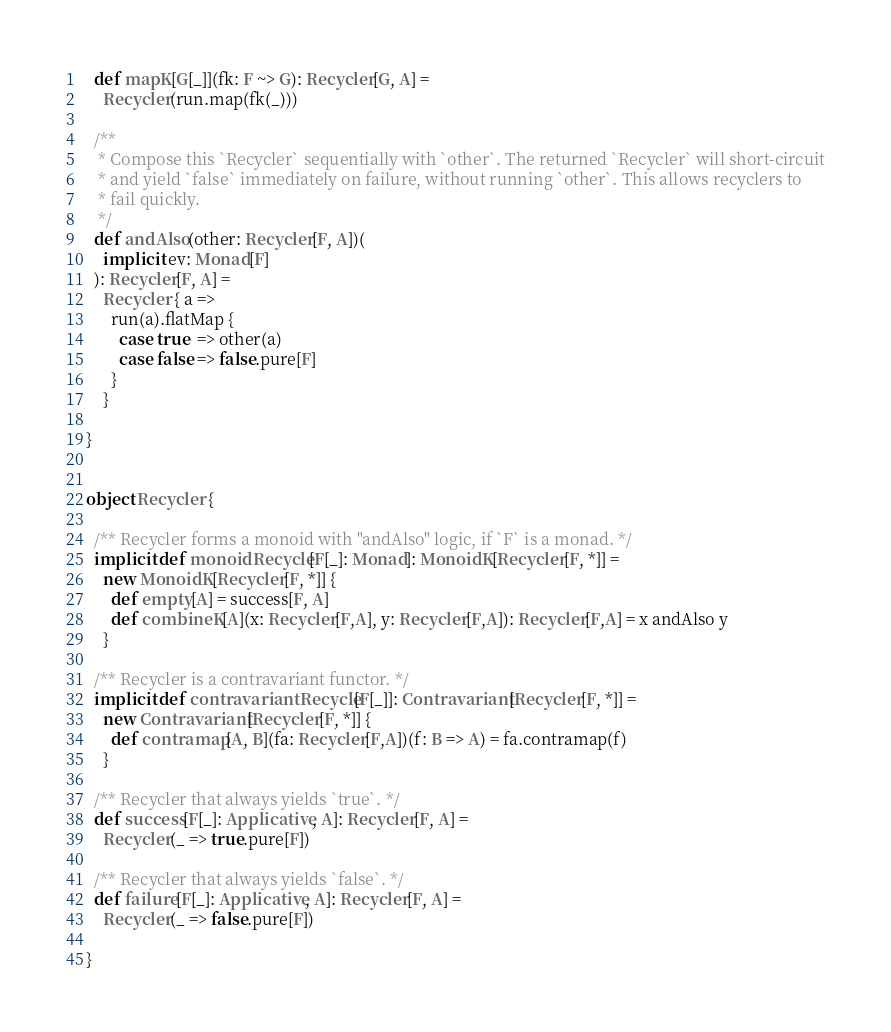Convert code to text. <code><loc_0><loc_0><loc_500><loc_500><_Scala_>  def mapK[G[_]](fk: F ~> G): Recycler[G, A] =
    Recycler(run.map(fk(_)))

  /**
   * Compose this `Recycler` sequentially with `other`. The returned `Recycler` will short-circuit
   * and yield `false` immediately on failure, without running `other`. This allows recyclers to
   * fail quickly.
   */
  def andAlso(other: Recycler[F, A])(
    implicit ev: Monad[F]
  ): Recycler[F, A] =
    Recycler { a =>
      run(a).flatMap {
        case true  => other(a)
        case false => false.pure[F]
      }
    }

}


object Recycler {

  /** Recycler forms a monoid with "andAlso" logic, if `F` is a monad. */
  implicit def monoidRecycle[F[_]: Monad]: MonoidK[Recycler[F, *]] =
    new MonoidK[Recycler[F, *]] {
      def empty[A] = success[F, A]
      def combineK[A](x: Recycler[F,A], y: Recycler[F,A]): Recycler[F,A] = x andAlso y
    }

  /** Recycler is a contravariant functor. */
  implicit def contravariantRecycle[F[_]]: Contravariant[Recycler[F, *]] =
    new Contravariant[Recycler[F, *]] {
      def contramap[A, B](fa: Recycler[F,A])(f: B => A) = fa.contramap(f)
    }

  /** Recycler that always yields `true`. */
  def success[F[_]: Applicative, A]: Recycler[F, A] =
    Recycler(_ => true.pure[F])

  /** Recycler that always yields `false`. */
  def failure[F[_]: Applicative, A]: Recycler[F, A] =
    Recycler(_ => false.pure[F])

}
</code> 